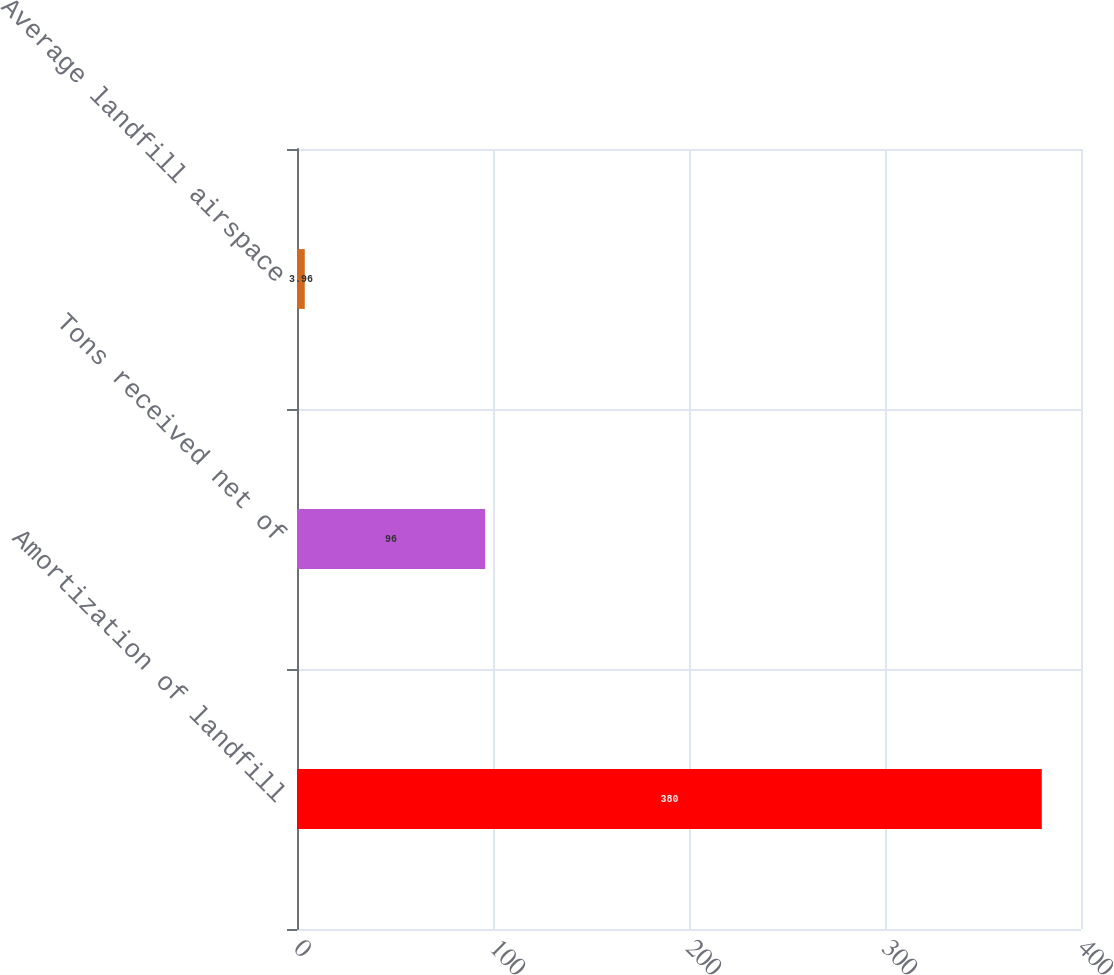Convert chart. <chart><loc_0><loc_0><loc_500><loc_500><bar_chart><fcel>Amortization of landfill<fcel>Tons received net of<fcel>Average landfill airspace<nl><fcel>380<fcel>96<fcel>3.96<nl></chart> 